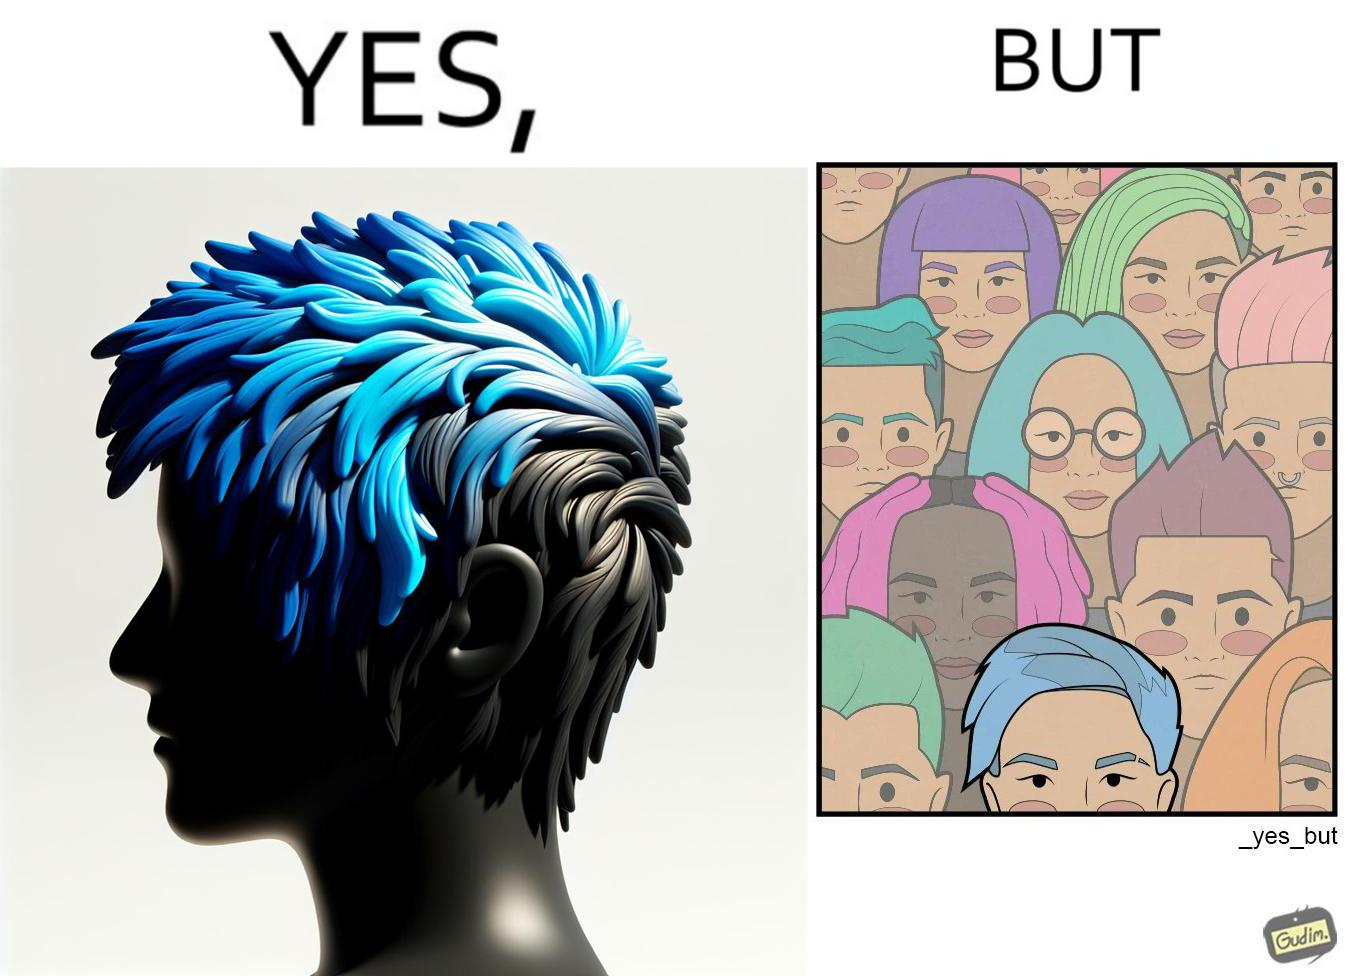What does this image depict? The image is funny, as one person with a hair dyed blue seems to symbolize that the person is going against the grain, however, when we zoom out, the group of people have hair dyed in several, different colors, showing that, dyeing hair is the new normal. 